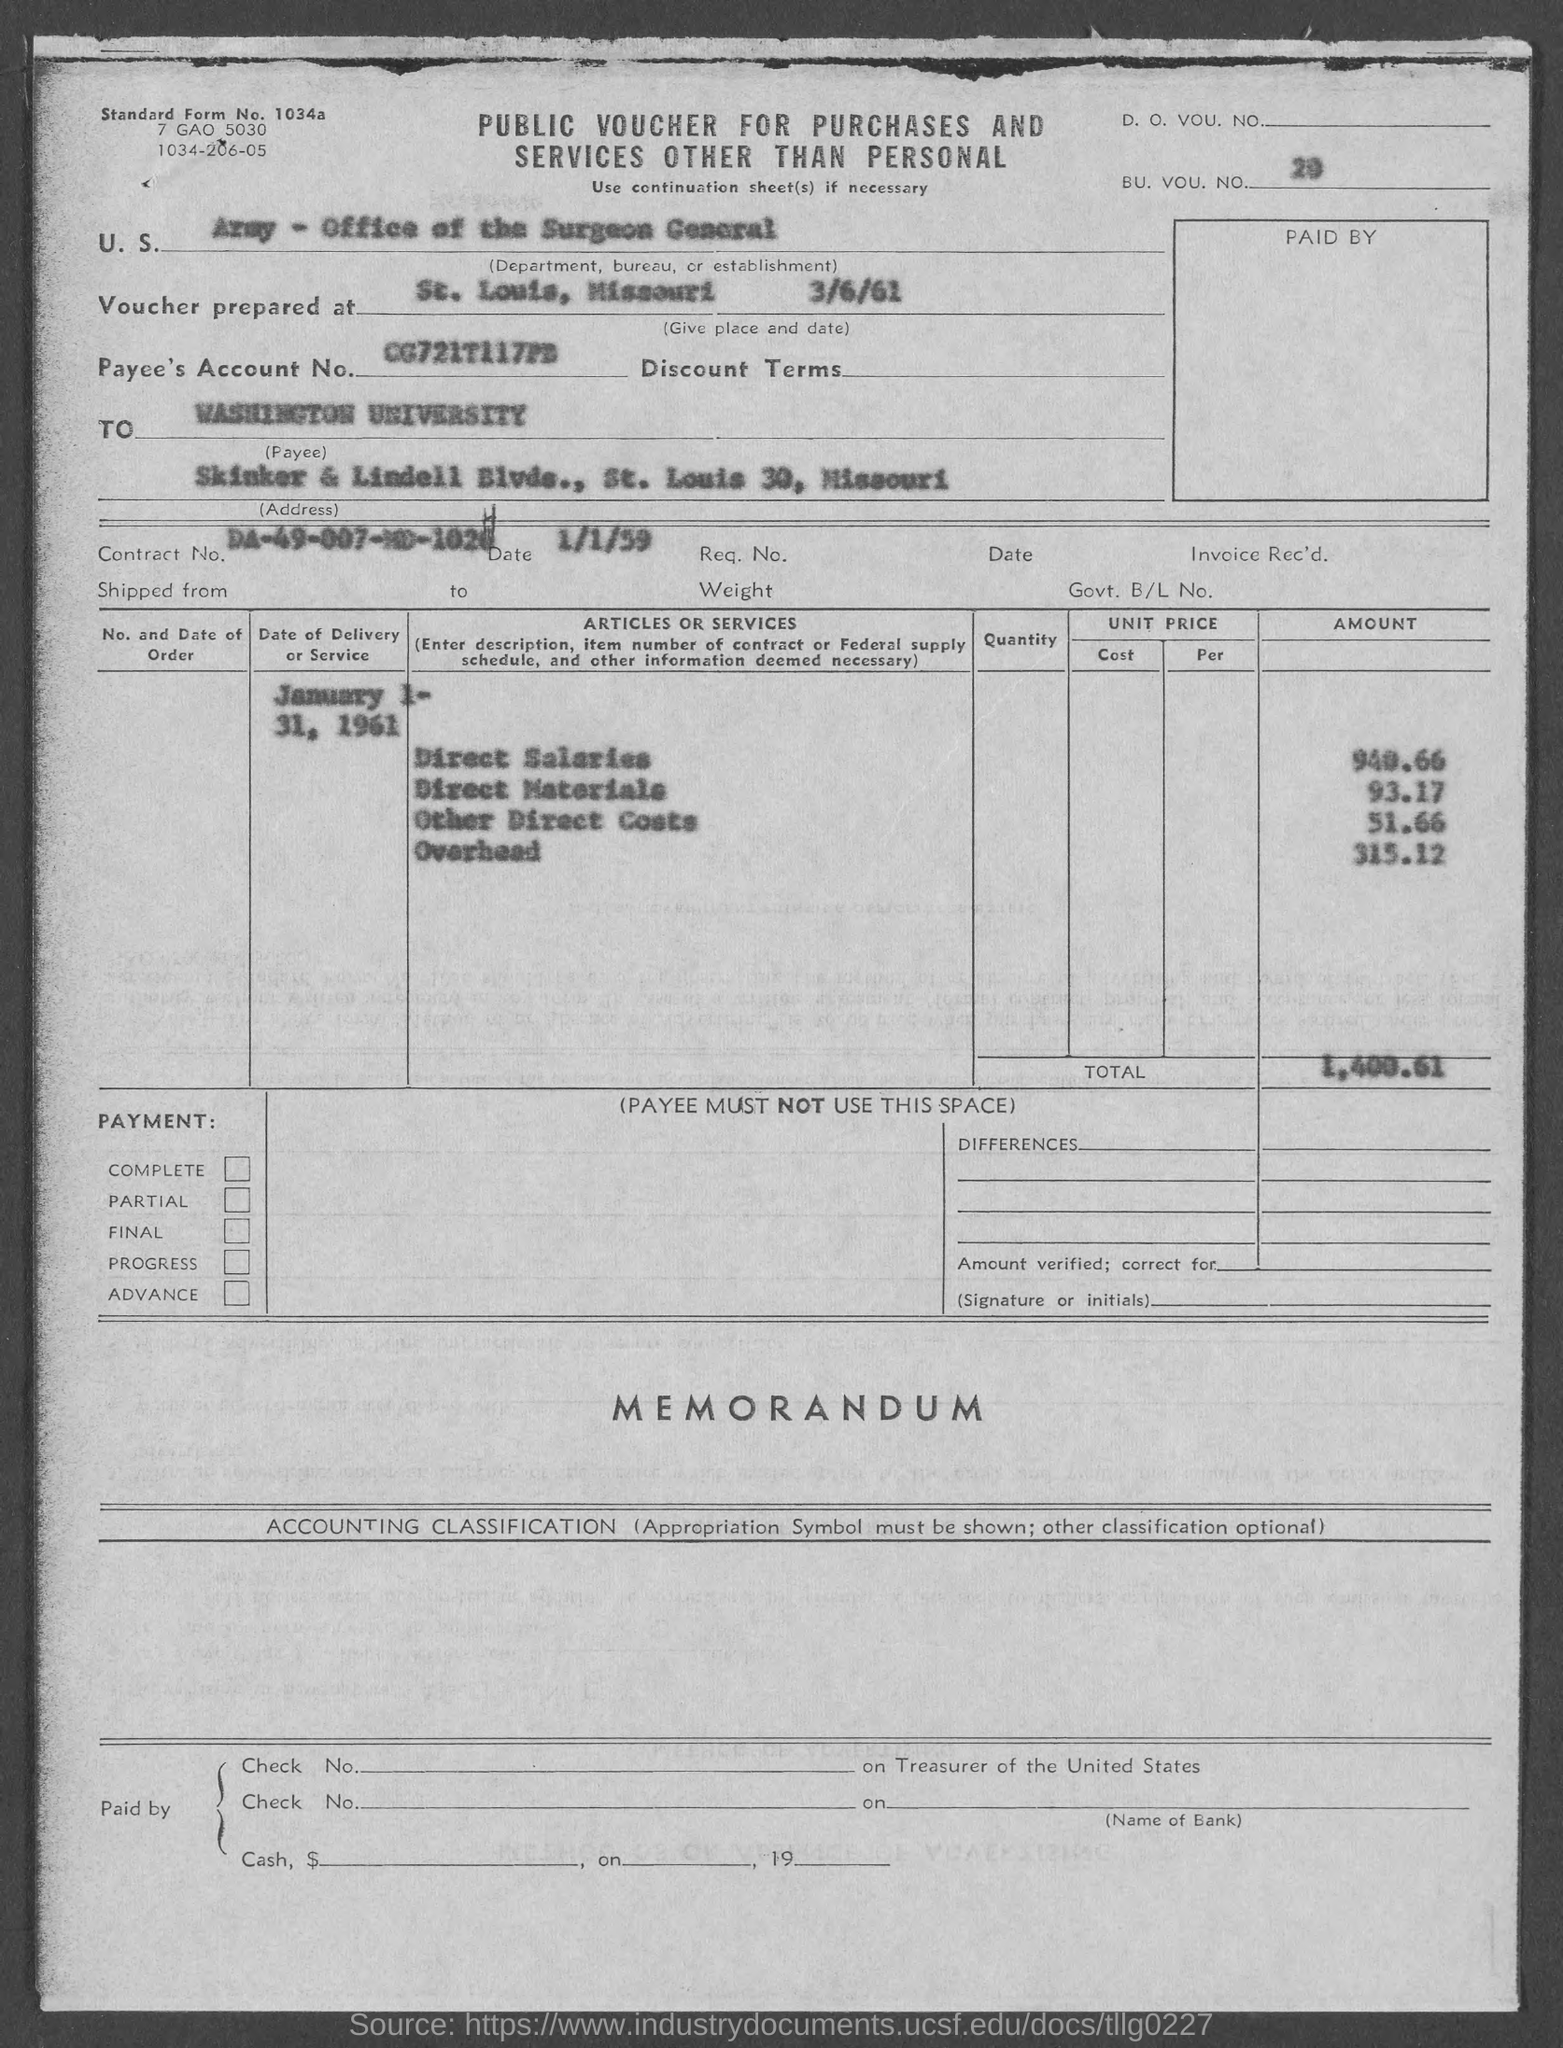Mention a couple of crucial points in this snapshot. The voucher lists the U.S. Department, Bureau, or Establishment as the Army - Office of the Surgeon General. The voucher mentions a BU. VOU. NO. of 20... in its contents. The voucher amount mentioned in the document is 1,400.61," stated the user. The direct materials cost given in the voucher is 93.17. The payee's account number listed in the voucher is CG721T117PB... 